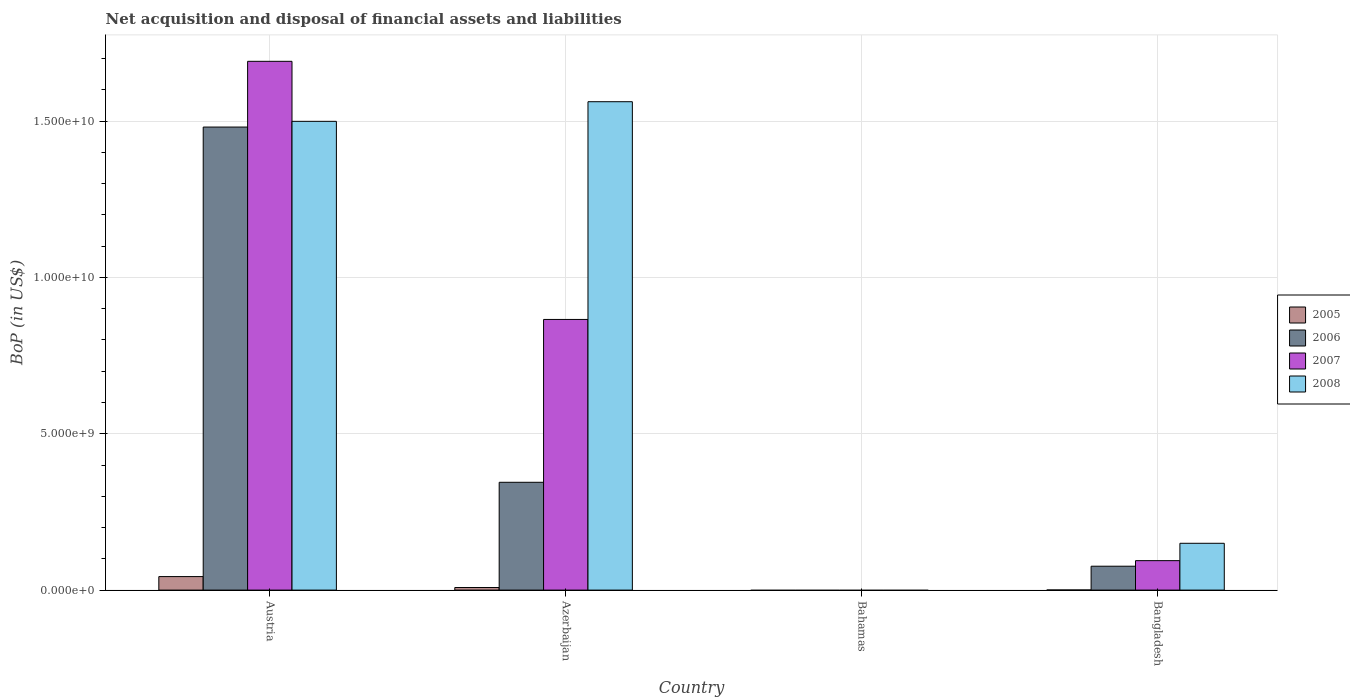What is the label of the 4th group of bars from the left?
Offer a very short reply. Bangladesh. What is the Balance of Payments in 2006 in Bangladesh?
Your answer should be compact. 7.64e+08. Across all countries, what is the maximum Balance of Payments in 2007?
Ensure brevity in your answer.  1.69e+1. Across all countries, what is the minimum Balance of Payments in 2008?
Provide a short and direct response. 0. In which country was the Balance of Payments in 2008 maximum?
Provide a short and direct response. Azerbaijan. What is the total Balance of Payments in 2006 in the graph?
Your answer should be compact. 1.90e+1. What is the difference between the Balance of Payments in 2008 in Austria and that in Bangladesh?
Your response must be concise. 1.35e+1. What is the difference between the Balance of Payments in 2005 in Bangladesh and the Balance of Payments in 2007 in Bahamas?
Your answer should be compact. 3.42e+06. What is the average Balance of Payments in 2007 per country?
Give a very brief answer. 6.63e+09. What is the difference between the Balance of Payments of/in 2005 and Balance of Payments of/in 2006 in Bangladesh?
Keep it short and to the point. -7.60e+08. In how many countries, is the Balance of Payments in 2005 greater than 14000000000 US$?
Provide a succinct answer. 0. What is the ratio of the Balance of Payments in 2005 in Azerbaijan to that in Bangladesh?
Your answer should be compact. 24.16. Is the Balance of Payments in 2006 in Austria less than that in Azerbaijan?
Your answer should be compact. No. What is the difference between the highest and the second highest Balance of Payments in 2005?
Provide a short and direct response. 4.29e+08. What is the difference between the highest and the lowest Balance of Payments in 2007?
Provide a short and direct response. 1.69e+1. Is it the case that in every country, the sum of the Balance of Payments in 2007 and Balance of Payments in 2008 is greater than the Balance of Payments in 2005?
Provide a succinct answer. No. Are all the bars in the graph horizontal?
Keep it short and to the point. No. Does the graph contain any zero values?
Ensure brevity in your answer.  Yes. Does the graph contain grids?
Offer a very short reply. Yes. What is the title of the graph?
Make the answer very short. Net acquisition and disposal of financial assets and liabilities. What is the label or title of the X-axis?
Make the answer very short. Country. What is the label or title of the Y-axis?
Your answer should be very brief. BoP (in US$). What is the BoP (in US$) in 2005 in Austria?
Offer a terse response. 4.32e+08. What is the BoP (in US$) in 2006 in Austria?
Keep it short and to the point. 1.48e+1. What is the BoP (in US$) in 2007 in Austria?
Offer a very short reply. 1.69e+1. What is the BoP (in US$) of 2008 in Austria?
Give a very brief answer. 1.50e+1. What is the BoP (in US$) of 2005 in Azerbaijan?
Ensure brevity in your answer.  8.26e+07. What is the BoP (in US$) of 2006 in Azerbaijan?
Your answer should be compact. 3.45e+09. What is the BoP (in US$) of 2007 in Azerbaijan?
Ensure brevity in your answer.  8.66e+09. What is the BoP (in US$) in 2008 in Azerbaijan?
Give a very brief answer. 1.56e+1. What is the BoP (in US$) in 2007 in Bahamas?
Provide a succinct answer. 0. What is the BoP (in US$) in 2005 in Bangladesh?
Offer a terse response. 3.42e+06. What is the BoP (in US$) of 2006 in Bangladesh?
Provide a short and direct response. 7.64e+08. What is the BoP (in US$) of 2007 in Bangladesh?
Keep it short and to the point. 9.42e+08. What is the BoP (in US$) in 2008 in Bangladesh?
Keep it short and to the point. 1.50e+09. Across all countries, what is the maximum BoP (in US$) in 2005?
Ensure brevity in your answer.  4.32e+08. Across all countries, what is the maximum BoP (in US$) of 2006?
Keep it short and to the point. 1.48e+1. Across all countries, what is the maximum BoP (in US$) of 2007?
Provide a short and direct response. 1.69e+1. Across all countries, what is the maximum BoP (in US$) of 2008?
Your answer should be compact. 1.56e+1. Across all countries, what is the minimum BoP (in US$) of 2005?
Offer a terse response. 0. Across all countries, what is the minimum BoP (in US$) of 2006?
Give a very brief answer. 0. What is the total BoP (in US$) in 2005 in the graph?
Ensure brevity in your answer.  5.18e+08. What is the total BoP (in US$) of 2006 in the graph?
Provide a succinct answer. 1.90e+1. What is the total BoP (in US$) in 2007 in the graph?
Make the answer very short. 2.65e+1. What is the total BoP (in US$) of 2008 in the graph?
Offer a very short reply. 3.21e+1. What is the difference between the BoP (in US$) of 2005 in Austria and that in Azerbaijan?
Offer a very short reply. 3.50e+08. What is the difference between the BoP (in US$) of 2006 in Austria and that in Azerbaijan?
Make the answer very short. 1.14e+1. What is the difference between the BoP (in US$) in 2007 in Austria and that in Azerbaijan?
Your answer should be very brief. 8.26e+09. What is the difference between the BoP (in US$) in 2008 in Austria and that in Azerbaijan?
Make the answer very short. -6.27e+08. What is the difference between the BoP (in US$) of 2005 in Austria and that in Bangladesh?
Offer a terse response. 4.29e+08. What is the difference between the BoP (in US$) in 2006 in Austria and that in Bangladesh?
Offer a terse response. 1.40e+1. What is the difference between the BoP (in US$) in 2007 in Austria and that in Bangladesh?
Give a very brief answer. 1.60e+1. What is the difference between the BoP (in US$) in 2008 in Austria and that in Bangladesh?
Offer a terse response. 1.35e+1. What is the difference between the BoP (in US$) of 2005 in Azerbaijan and that in Bangladesh?
Your answer should be compact. 7.92e+07. What is the difference between the BoP (in US$) of 2006 in Azerbaijan and that in Bangladesh?
Offer a terse response. 2.68e+09. What is the difference between the BoP (in US$) of 2007 in Azerbaijan and that in Bangladesh?
Your answer should be very brief. 7.71e+09. What is the difference between the BoP (in US$) of 2008 in Azerbaijan and that in Bangladesh?
Ensure brevity in your answer.  1.41e+1. What is the difference between the BoP (in US$) of 2005 in Austria and the BoP (in US$) of 2006 in Azerbaijan?
Give a very brief answer. -3.02e+09. What is the difference between the BoP (in US$) of 2005 in Austria and the BoP (in US$) of 2007 in Azerbaijan?
Offer a terse response. -8.22e+09. What is the difference between the BoP (in US$) of 2005 in Austria and the BoP (in US$) of 2008 in Azerbaijan?
Your response must be concise. -1.52e+1. What is the difference between the BoP (in US$) in 2006 in Austria and the BoP (in US$) in 2007 in Azerbaijan?
Give a very brief answer. 6.15e+09. What is the difference between the BoP (in US$) of 2006 in Austria and the BoP (in US$) of 2008 in Azerbaijan?
Offer a very short reply. -8.11e+08. What is the difference between the BoP (in US$) in 2007 in Austria and the BoP (in US$) in 2008 in Azerbaijan?
Your answer should be very brief. 1.29e+09. What is the difference between the BoP (in US$) in 2005 in Austria and the BoP (in US$) in 2006 in Bangladesh?
Ensure brevity in your answer.  -3.32e+08. What is the difference between the BoP (in US$) of 2005 in Austria and the BoP (in US$) of 2007 in Bangladesh?
Your answer should be very brief. -5.10e+08. What is the difference between the BoP (in US$) in 2005 in Austria and the BoP (in US$) in 2008 in Bangladesh?
Give a very brief answer. -1.06e+09. What is the difference between the BoP (in US$) of 2006 in Austria and the BoP (in US$) of 2007 in Bangladesh?
Offer a very short reply. 1.39e+1. What is the difference between the BoP (in US$) of 2006 in Austria and the BoP (in US$) of 2008 in Bangladesh?
Your response must be concise. 1.33e+1. What is the difference between the BoP (in US$) in 2007 in Austria and the BoP (in US$) in 2008 in Bangladesh?
Provide a succinct answer. 1.54e+1. What is the difference between the BoP (in US$) in 2005 in Azerbaijan and the BoP (in US$) in 2006 in Bangladesh?
Ensure brevity in your answer.  -6.81e+08. What is the difference between the BoP (in US$) in 2005 in Azerbaijan and the BoP (in US$) in 2007 in Bangladesh?
Offer a very short reply. -8.59e+08. What is the difference between the BoP (in US$) of 2005 in Azerbaijan and the BoP (in US$) of 2008 in Bangladesh?
Make the answer very short. -1.41e+09. What is the difference between the BoP (in US$) of 2006 in Azerbaijan and the BoP (in US$) of 2007 in Bangladesh?
Provide a short and direct response. 2.51e+09. What is the difference between the BoP (in US$) of 2006 in Azerbaijan and the BoP (in US$) of 2008 in Bangladesh?
Offer a very short reply. 1.95e+09. What is the difference between the BoP (in US$) of 2007 in Azerbaijan and the BoP (in US$) of 2008 in Bangladesh?
Offer a terse response. 7.16e+09. What is the average BoP (in US$) of 2005 per country?
Your answer should be compact. 1.30e+08. What is the average BoP (in US$) of 2006 per country?
Keep it short and to the point. 4.75e+09. What is the average BoP (in US$) of 2007 per country?
Your response must be concise. 6.63e+09. What is the average BoP (in US$) in 2008 per country?
Your answer should be very brief. 8.03e+09. What is the difference between the BoP (in US$) in 2005 and BoP (in US$) in 2006 in Austria?
Provide a short and direct response. -1.44e+1. What is the difference between the BoP (in US$) of 2005 and BoP (in US$) of 2007 in Austria?
Make the answer very short. -1.65e+1. What is the difference between the BoP (in US$) in 2005 and BoP (in US$) in 2008 in Austria?
Your answer should be very brief. -1.46e+1. What is the difference between the BoP (in US$) in 2006 and BoP (in US$) in 2007 in Austria?
Ensure brevity in your answer.  -2.10e+09. What is the difference between the BoP (in US$) in 2006 and BoP (in US$) in 2008 in Austria?
Your answer should be compact. -1.83e+08. What is the difference between the BoP (in US$) in 2007 and BoP (in US$) in 2008 in Austria?
Make the answer very short. 1.92e+09. What is the difference between the BoP (in US$) in 2005 and BoP (in US$) in 2006 in Azerbaijan?
Offer a terse response. -3.37e+09. What is the difference between the BoP (in US$) of 2005 and BoP (in US$) of 2007 in Azerbaijan?
Your answer should be compact. -8.57e+09. What is the difference between the BoP (in US$) in 2005 and BoP (in US$) in 2008 in Azerbaijan?
Give a very brief answer. -1.55e+1. What is the difference between the BoP (in US$) in 2006 and BoP (in US$) in 2007 in Azerbaijan?
Provide a succinct answer. -5.21e+09. What is the difference between the BoP (in US$) of 2006 and BoP (in US$) of 2008 in Azerbaijan?
Offer a very short reply. -1.22e+1. What is the difference between the BoP (in US$) of 2007 and BoP (in US$) of 2008 in Azerbaijan?
Provide a short and direct response. -6.96e+09. What is the difference between the BoP (in US$) in 2005 and BoP (in US$) in 2006 in Bangladesh?
Your answer should be very brief. -7.60e+08. What is the difference between the BoP (in US$) in 2005 and BoP (in US$) in 2007 in Bangladesh?
Provide a succinct answer. -9.39e+08. What is the difference between the BoP (in US$) of 2005 and BoP (in US$) of 2008 in Bangladesh?
Your answer should be compact. -1.49e+09. What is the difference between the BoP (in US$) of 2006 and BoP (in US$) of 2007 in Bangladesh?
Keep it short and to the point. -1.78e+08. What is the difference between the BoP (in US$) in 2006 and BoP (in US$) in 2008 in Bangladesh?
Offer a terse response. -7.33e+08. What is the difference between the BoP (in US$) of 2007 and BoP (in US$) of 2008 in Bangladesh?
Your response must be concise. -5.55e+08. What is the ratio of the BoP (in US$) of 2005 in Austria to that in Azerbaijan?
Provide a succinct answer. 5.23. What is the ratio of the BoP (in US$) of 2006 in Austria to that in Azerbaijan?
Ensure brevity in your answer.  4.29. What is the ratio of the BoP (in US$) in 2007 in Austria to that in Azerbaijan?
Offer a very short reply. 1.95. What is the ratio of the BoP (in US$) of 2008 in Austria to that in Azerbaijan?
Keep it short and to the point. 0.96. What is the ratio of the BoP (in US$) in 2005 in Austria to that in Bangladesh?
Your answer should be very brief. 126.38. What is the ratio of the BoP (in US$) of 2006 in Austria to that in Bangladesh?
Your answer should be compact. 19.39. What is the ratio of the BoP (in US$) in 2007 in Austria to that in Bangladesh?
Provide a succinct answer. 17.95. What is the ratio of the BoP (in US$) of 2008 in Austria to that in Bangladesh?
Ensure brevity in your answer.  10.01. What is the ratio of the BoP (in US$) in 2005 in Azerbaijan to that in Bangladesh?
Give a very brief answer. 24.16. What is the ratio of the BoP (in US$) of 2006 in Azerbaijan to that in Bangladesh?
Offer a very short reply. 4.51. What is the ratio of the BoP (in US$) of 2007 in Azerbaijan to that in Bangladesh?
Provide a short and direct response. 9.19. What is the ratio of the BoP (in US$) of 2008 in Azerbaijan to that in Bangladesh?
Give a very brief answer. 10.43. What is the difference between the highest and the second highest BoP (in US$) in 2005?
Offer a very short reply. 3.50e+08. What is the difference between the highest and the second highest BoP (in US$) of 2006?
Make the answer very short. 1.14e+1. What is the difference between the highest and the second highest BoP (in US$) in 2007?
Your answer should be very brief. 8.26e+09. What is the difference between the highest and the second highest BoP (in US$) of 2008?
Ensure brevity in your answer.  6.27e+08. What is the difference between the highest and the lowest BoP (in US$) of 2005?
Provide a short and direct response. 4.32e+08. What is the difference between the highest and the lowest BoP (in US$) of 2006?
Keep it short and to the point. 1.48e+1. What is the difference between the highest and the lowest BoP (in US$) in 2007?
Offer a terse response. 1.69e+1. What is the difference between the highest and the lowest BoP (in US$) in 2008?
Offer a very short reply. 1.56e+1. 